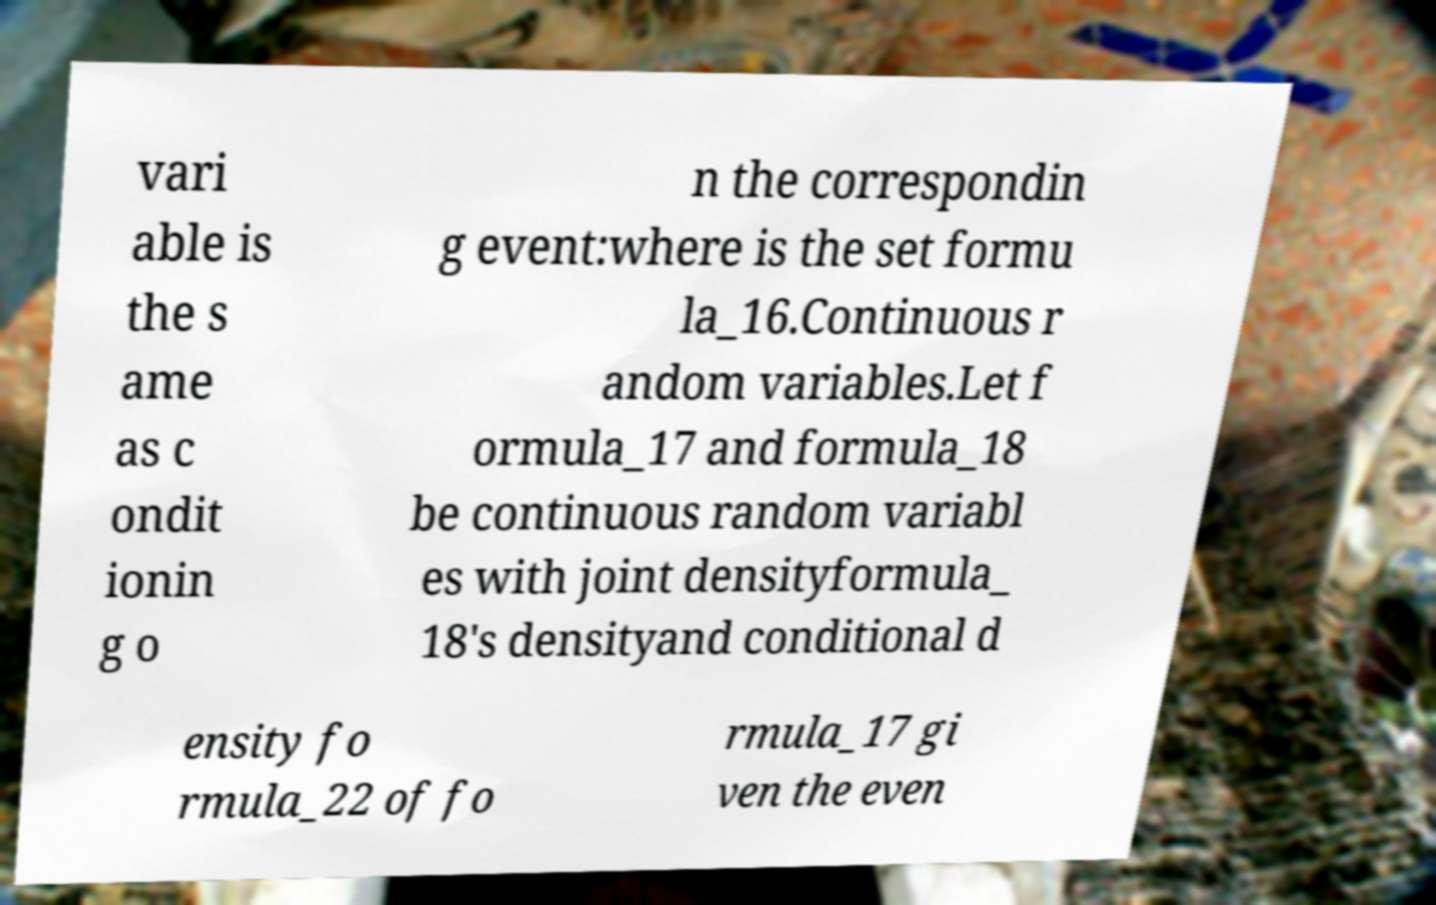For documentation purposes, I need the text within this image transcribed. Could you provide that? vari able is the s ame as c ondit ionin g o n the correspondin g event:where is the set formu la_16.Continuous r andom variables.Let f ormula_17 and formula_18 be continuous random variabl es with joint densityformula_ 18's densityand conditional d ensity fo rmula_22 of fo rmula_17 gi ven the even 